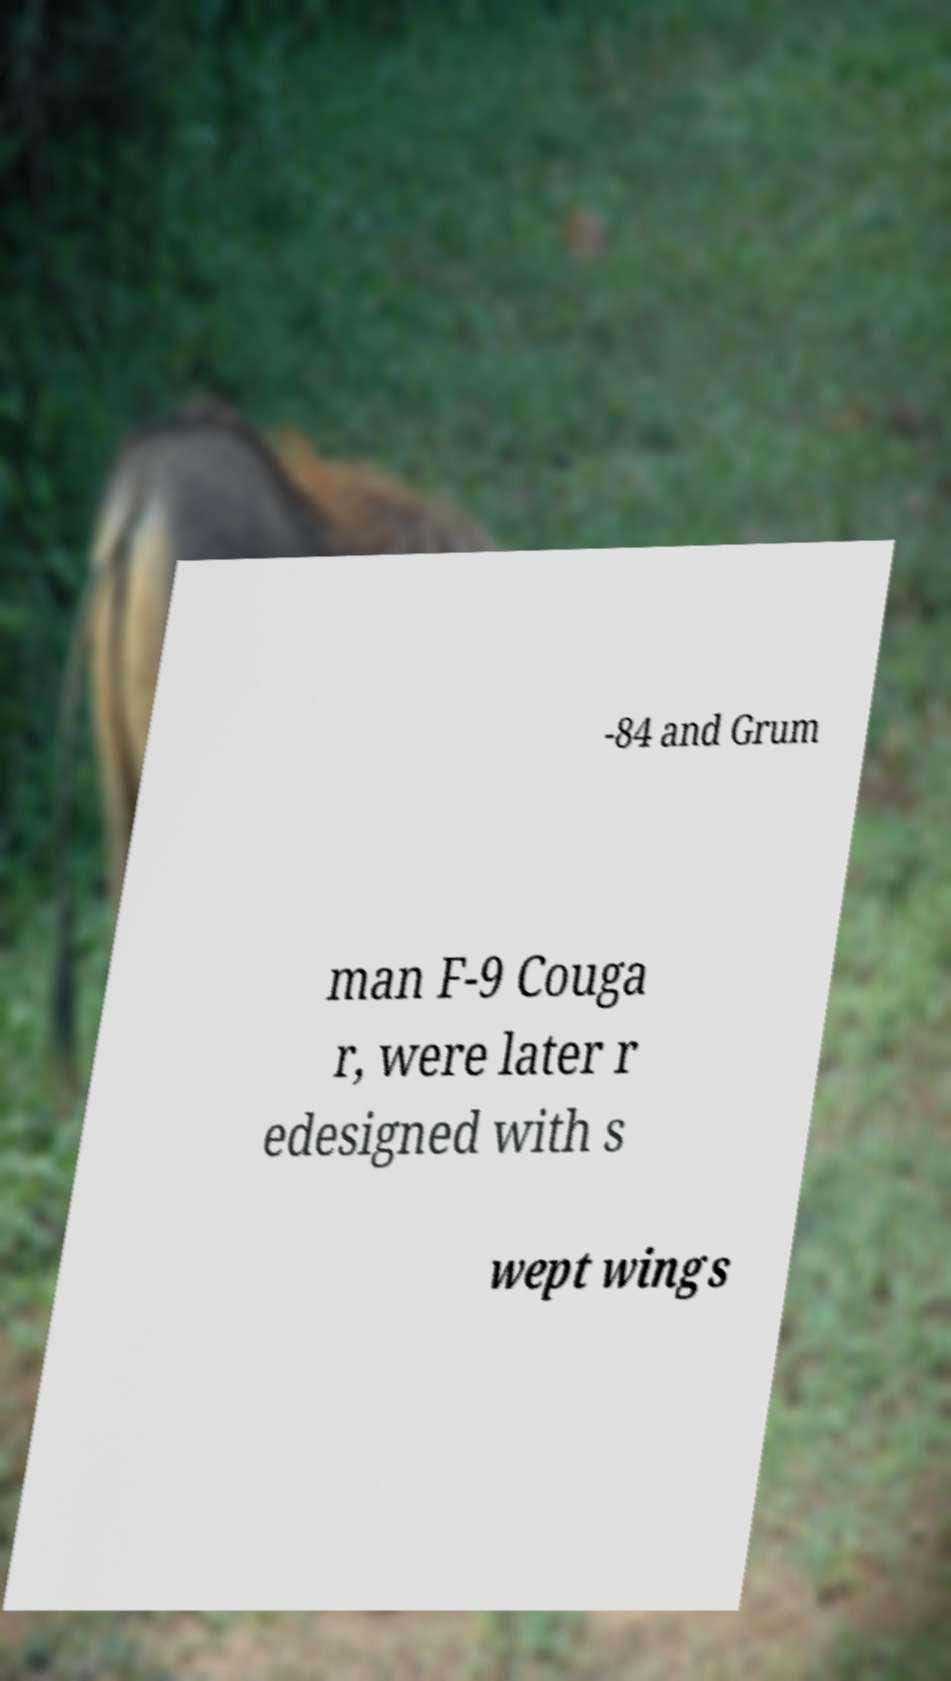For documentation purposes, I need the text within this image transcribed. Could you provide that? -84 and Grum man F-9 Couga r, were later r edesigned with s wept wings 